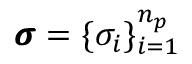<formula> <loc_0><loc_0><loc_500><loc_500>\pm b { \sigma } = \{ \sigma _ { i } \} _ { i = 1 } ^ { n _ { p } }</formula> 